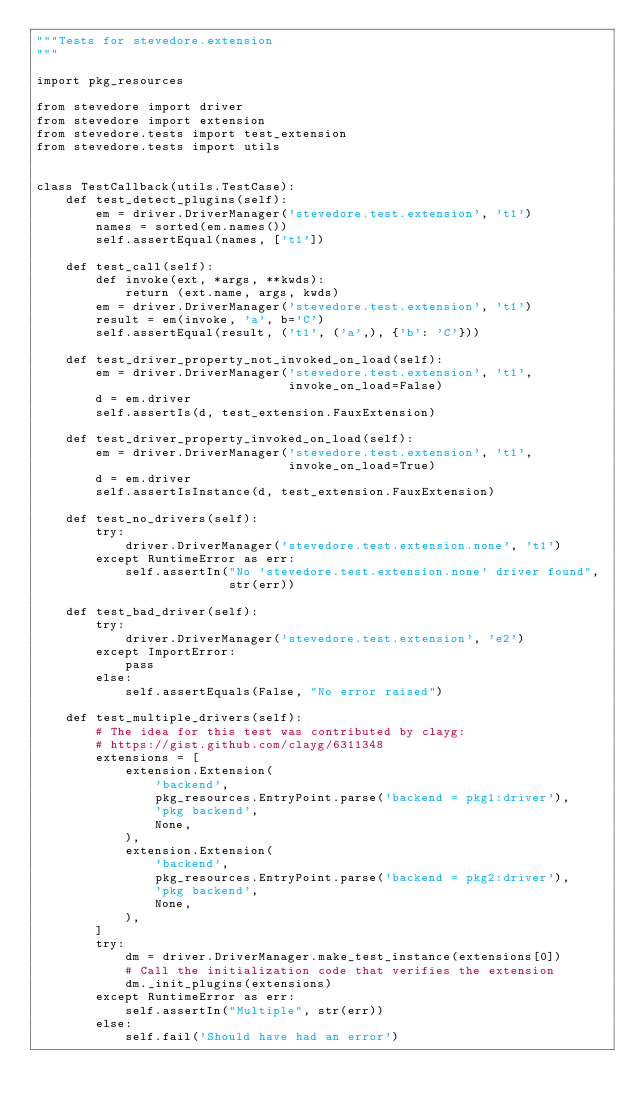<code> <loc_0><loc_0><loc_500><loc_500><_Python_>"""Tests for stevedore.extension
"""

import pkg_resources

from stevedore import driver
from stevedore import extension
from stevedore.tests import test_extension
from stevedore.tests import utils


class TestCallback(utils.TestCase):
    def test_detect_plugins(self):
        em = driver.DriverManager('stevedore.test.extension', 't1')
        names = sorted(em.names())
        self.assertEqual(names, ['t1'])

    def test_call(self):
        def invoke(ext, *args, **kwds):
            return (ext.name, args, kwds)
        em = driver.DriverManager('stevedore.test.extension', 't1')
        result = em(invoke, 'a', b='C')
        self.assertEqual(result, ('t1', ('a',), {'b': 'C'}))

    def test_driver_property_not_invoked_on_load(self):
        em = driver.DriverManager('stevedore.test.extension', 't1',
                                  invoke_on_load=False)
        d = em.driver
        self.assertIs(d, test_extension.FauxExtension)

    def test_driver_property_invoked_on_load(self):
        em = driver.DriverManager('stevedore.test.extension', 't1',
                                  invoke_on_load=True)
        d = em.driver
        self.assertIsInstance(d, test_extension.FauxExtension)

    def test_no_drivers(self):
        try:
            driver.DriverManager('stevedore.test.extension.none', 't1')
        except RuntimeError as err:
            self.assertIn("No 'stevedore.test.extension.none' driver found",
                          str(err))

    def test_bad_driver(self):
        try:
            driver.DriverManager('stevedore.test.extension', 'e2')
        except ImportError:
            pass
        else:
            self.assertEquals(False, "No error raised")

    def test_multiple_drivers(self):
        # The idea for this test was contributed by clayg:
        # https://gist.github.com/clayg/6311348
        extensions = [
            extension.Extension(
                'backend',
                pkg_resources.EntryPoint.parse('backend = pkg1:driver'),
                'pkg backend',
                None,
            ),
            extension.Extension(
                'backend',
                pkg_resources.EntryPoint.parse('backend = pkg2:driver'),
                'pkg backend',
                None,
            ),
        ]
        try:
            dm = driver.DriverManager.make_test_instance(extensions[0])
            # Call the initialization code that verifies the extension
            dm._init_plugins(extensions)
        except RuntimeError as err:
            self.assertIn("Multiple", str(err))
        else:
            self.fail('Should have had an error')
</code> 